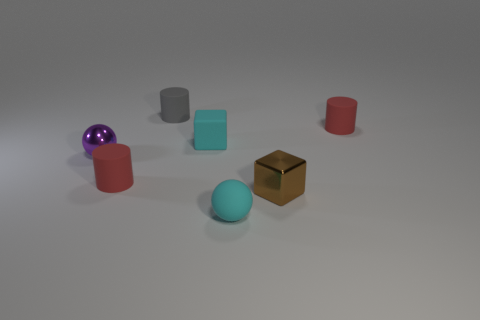Do the tiny cyan ball and the brown thing have the same material? The tiny cyan ball appears to have a matte surface, indicating it might be made of a material like plastic or rubber. The brown object, which resembles a small box, has a slightly reflective surface, suggesting it could be made of a polished wood or a metallic material. So based on visual clues, they appear to be made of different materials. 